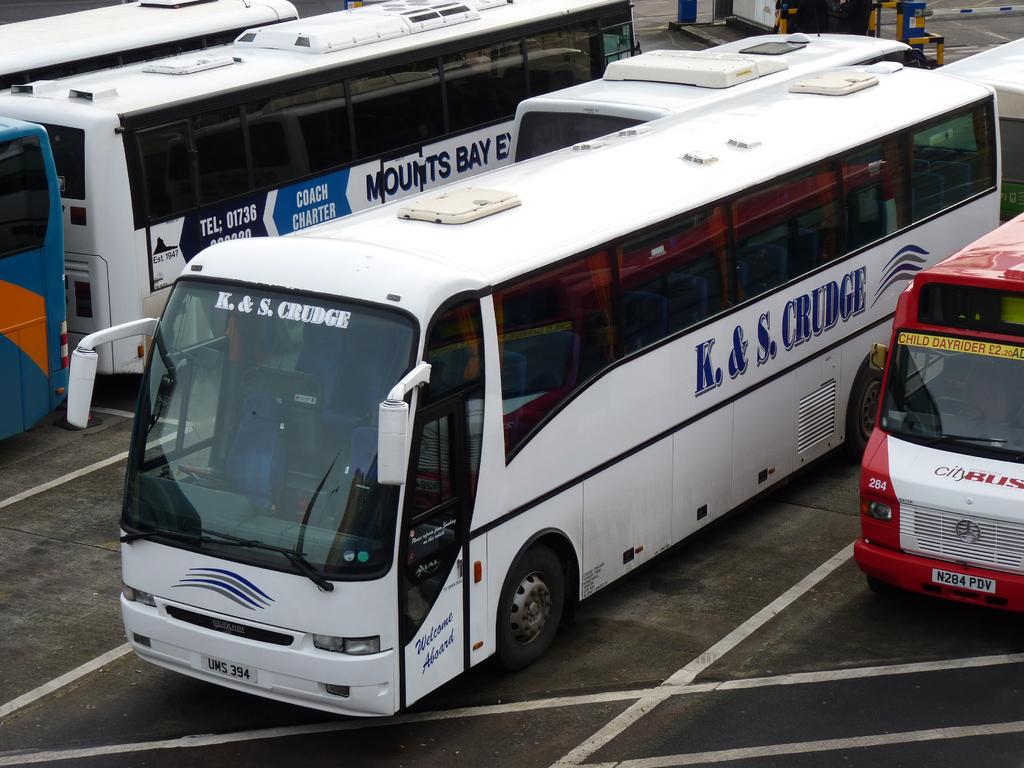What is the company name on the side of the bus?
Provide a short and direct response. K. & s. crudge. What are the numbers on the bus's license plate?
Your response must be concise. 394. 